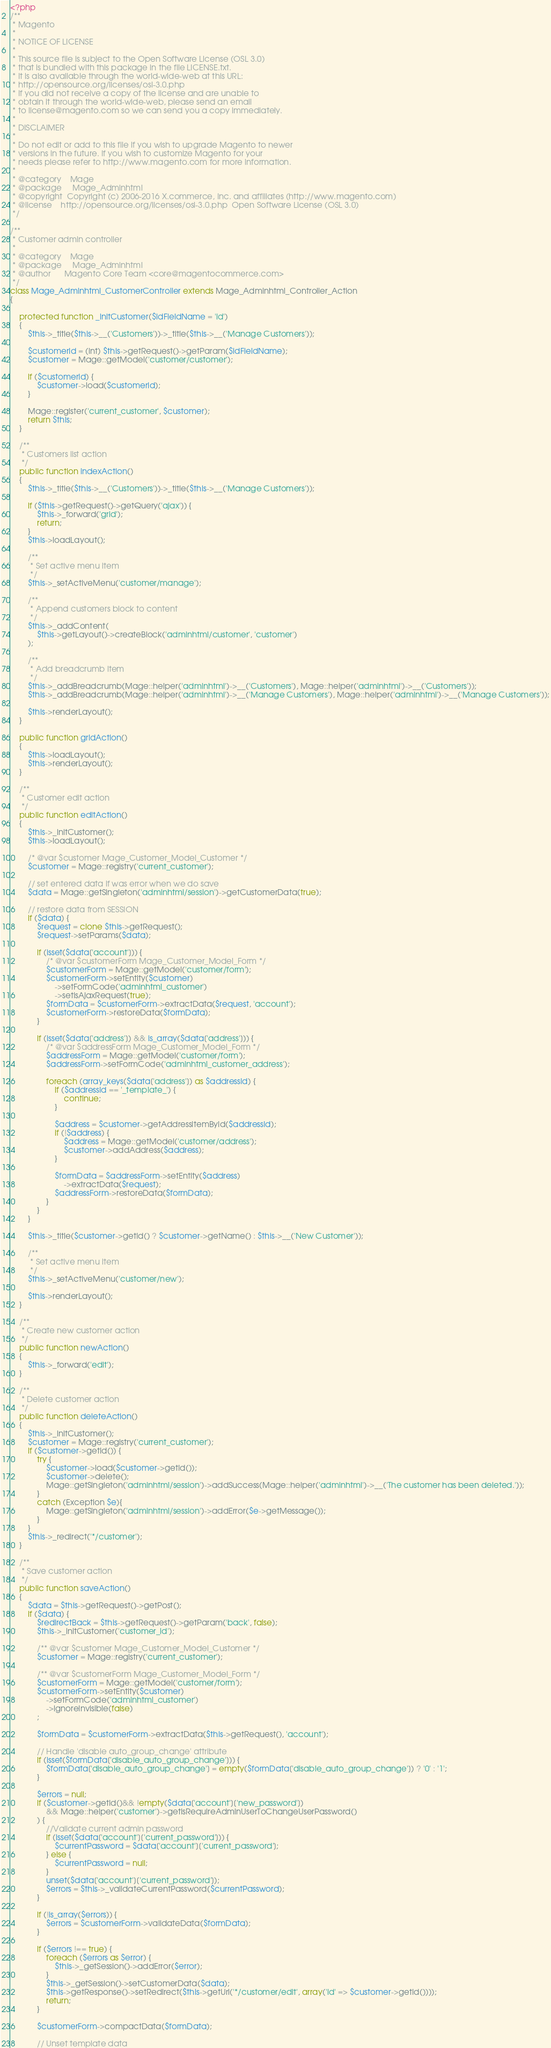<code> <loc_0><loc_0><loc_500><loc_500><_PHP_><?php
/**
 * Magento
 *
 * NOTICE OF LICENSE
 *
 * This source file is subject to the Open Software License (OSL 3.0)
 * that is bundled with this package in the file LICENSE.txt.
 * It is also available through the world-wide-web at this URL:
 * http://opensource.org/licenses/osl-3.0.php
 * If you did not receive a copy of the license and are unable to
 * obtain it through the world-wide-web, please send an email
 * to license@magento.com so we can send you a copy immediately.
 *
 * DISCLAIMER
 *
 * Do not edit or add to this file if you wish to upgrade Magento to newer
 * versions in the future. If you wish to customize Magento for your
 * needs please refer to http://www.magento.com for more information.
 *
 * @category    Mage
 * @package     Mage_Adminhtml
 * @copyright  Copyright (c) 2006-2016 X.commerce, Inc. and affiliates (http://www.magento.com)
 * @license    http://opensource.org/licenses/osl-3.0.php  Open Software License (OSL 3.0)
 */

/**
 * Customer admin controller
 *
 * @category    Mage
 * @package     Mage_Adminhtml
 * @author      Magento Core Team <core@magentocommerce.com>
 */
class Mage_Adminhtml_CustomerController extends Mage_Adminhtml_Controller_Action
{

    protected function _initCustomer($idFieldName = 'id')
    {
        $this->_title($this->__('Customers'))->_title($this->__('Manage Customers'));

        $customerId = (int) $this->getRequest()->getParam($idFieldName);
        $customer = Mage::getModel('customer/customer');

        if ($customerId) {
            $customer->load($customerId);
        }

        Mage::register('current_customer', $customer);
        return $this;
    }

    /**
     * Customers list action
     */
    public function indexAction()
    {
        $this->_title($this->__('Customers'))->_title($this->__('Manage Customers'));

        if ($this->getRequest()->getQuery('ajax')) {
            $this->_forward('grid');
            return;
        }
        $this->loadLayout();

        /**
         * Set active menu item
         */
        $this->_setActiveMenu('customer/manage');

        /**
         * Append customers block to content
         */
        $this->_addContent(
            $this->getLayout()->createBlock('adminhtml/customer', 'customer')
        );

        /**
         * Add breadcrumb item
         */
        $this->_addBreadcrumb(Mage::helper('adminhtml')->__('Customers'), Mage::helper('adminhtml')->__('Customers'));
        $this->_addBreadcrumb(Mage::helper('adminhtml')->__('Manage Customers'), Mage::helper('adminhtml')->__('Manage Customers'));

        $this->renderLayout();
    }

    public function gridAction()
    {
        $this->loadLayout();
        $this->renderLayout();
    }

    /**
     * Customer edit action
     */
    public function editAction()
    {
        $this->_initCustomer();
        $this->loadLayout();

        /* @var $customer Mage_Customer_Model_Customer */
        $customer = Mage::registry('current_customer');

        // set entered data if was error when we do save
        $data = Mage::getSingleton('adminhtml/session')->getCustomerData(true);

        // restore data from SESSION
        if ($data) {
            $request = clone $this->getRequest();
            $request->setParams($data);

            if (isset($data['account'])) {
                /* @var $customerForm Mage_Customer_Model_Form */
                $customerForm = Mage::getModel('customer/form');
                $customerForm->setEntity($customer)
                    ->setFormCode('adminhtml_customer')
                    ->setIsAjaxRequest(true);
                $formData = $customerForm->extractData($request, 'account');
                $customerForm->restoreData($formData);
            }

            if (isset($data['address']) && is_array($data['address'])) {
                /* @var $addressForm Mage_Customer_Model_Form */
                $addressForm = Mage::getModel('customer/form');
                $addressForm->setFormCode('adminhtml_customer_address');

                foreach (array_keys($data['address']) as $addressId) {
                    if ($addressId == '_template_') {
                        continue;
                    }

                    $address = $customer->getAddressItemById($addressId);
                    if (!$address) {
                        $address = Mage::getModel('customer/address');
                        $customer->addAddress($address);
                    }

                    $formData = $addressForm->setEntity($address)
                        ->extractData($request);
                    $addressForm->restoreData($formData);
                }
            }
        }

        $this->_title($customer->getId() ? $customer->getName() : $this->__('New Customer'));

        /**
         * Set active menu item
         */
        $this->_setActiveMenu('customer/new');

        $this->renderLayout();
    }

    /**
     * Create new customer action
     */
    public function newAction()
    {
        $this->_forward('edit');
    }

    /**
     * Delete customer action
     */
    public function deleteAction()
    {
        $this->_initCustomer();
        $customer = Mage::registry('current_customer');
        if ($customer->getId()) {
            try {
                $customer->load($customer->getId());
                $customer->delete();
                Mage::getSingleton('adminhtml/session')->addSuccess(Mage::helper('adminhtml')->__('The customer has been deleted.'));
            }
            catch (Exception $e){
                Mage::getSingleton('adminhtml/session')->addError($e->getMessage());
            }
        }
        $this->_redirect('*/customer');
    }

    /**
     * Save customer action
     */
    public function saveAction()
    {
        $data = $this->getRequest()->getPost();
        if ($data) {
            $redirectBack = $this->getRequest()->getParam('back', false);
            $this->_initCustomer('customer_id');

            /** @var $customer Mage_Customer_Model_Customer */
            $customer = Mage::registry('current_customer');

            /** @var $customerForm Mage_Customer_Model_Form */
            $customerForm = Mage::getModel('customer/form');
            $customerForm->setEntity($customer)
                ->setFormCode('adminhtml_customer')
                ->ignoreInvisible(false)
            ;

            $formData = $customerForm->extractData($this->getRequest(), 'account');

            // Handle 'disable auto_group_change' attribute
            if (isset($formData['disable_auto_group_change'])) {
                $formData['disable_auto_group_change'] = empty($formData['disable_auto_group_change']) ? '0' : '1';
            }

            $errors = null;
            if ($customer->getId()&& !empty($data['account']['new_password'])
                && Mage::helper('customer')->getIsRequireAdminUserToChangeUserPassword()
            ) {
                //Validate current admin password
                if (isset($data['account']['current_password'])) {
                    $currentPassword = $data['account']['current_password'];
                } else {
                    $currentPassword = null;
                }
                unset($data['account']['current_password']);
                $errors = $this->_validateCurrentPassword($currentPassword);
            }

            if (!is_array($errors)) {
                $errors = $customerForm->validateData($formData);
            }

            if ($errors !== true) {
                foreach ($errors as $error) {
                    $this->_getSession()->addError($error);
                }
                $this->_getSession()->setCustomerData($data);
                $this->getResponse()->setRedirect($this->getUrl('*/customer/edit', array('id' => $customer->getId())));
                return;
            }

            $customerForm->compactData($formData);

            // Unset template data</code> 